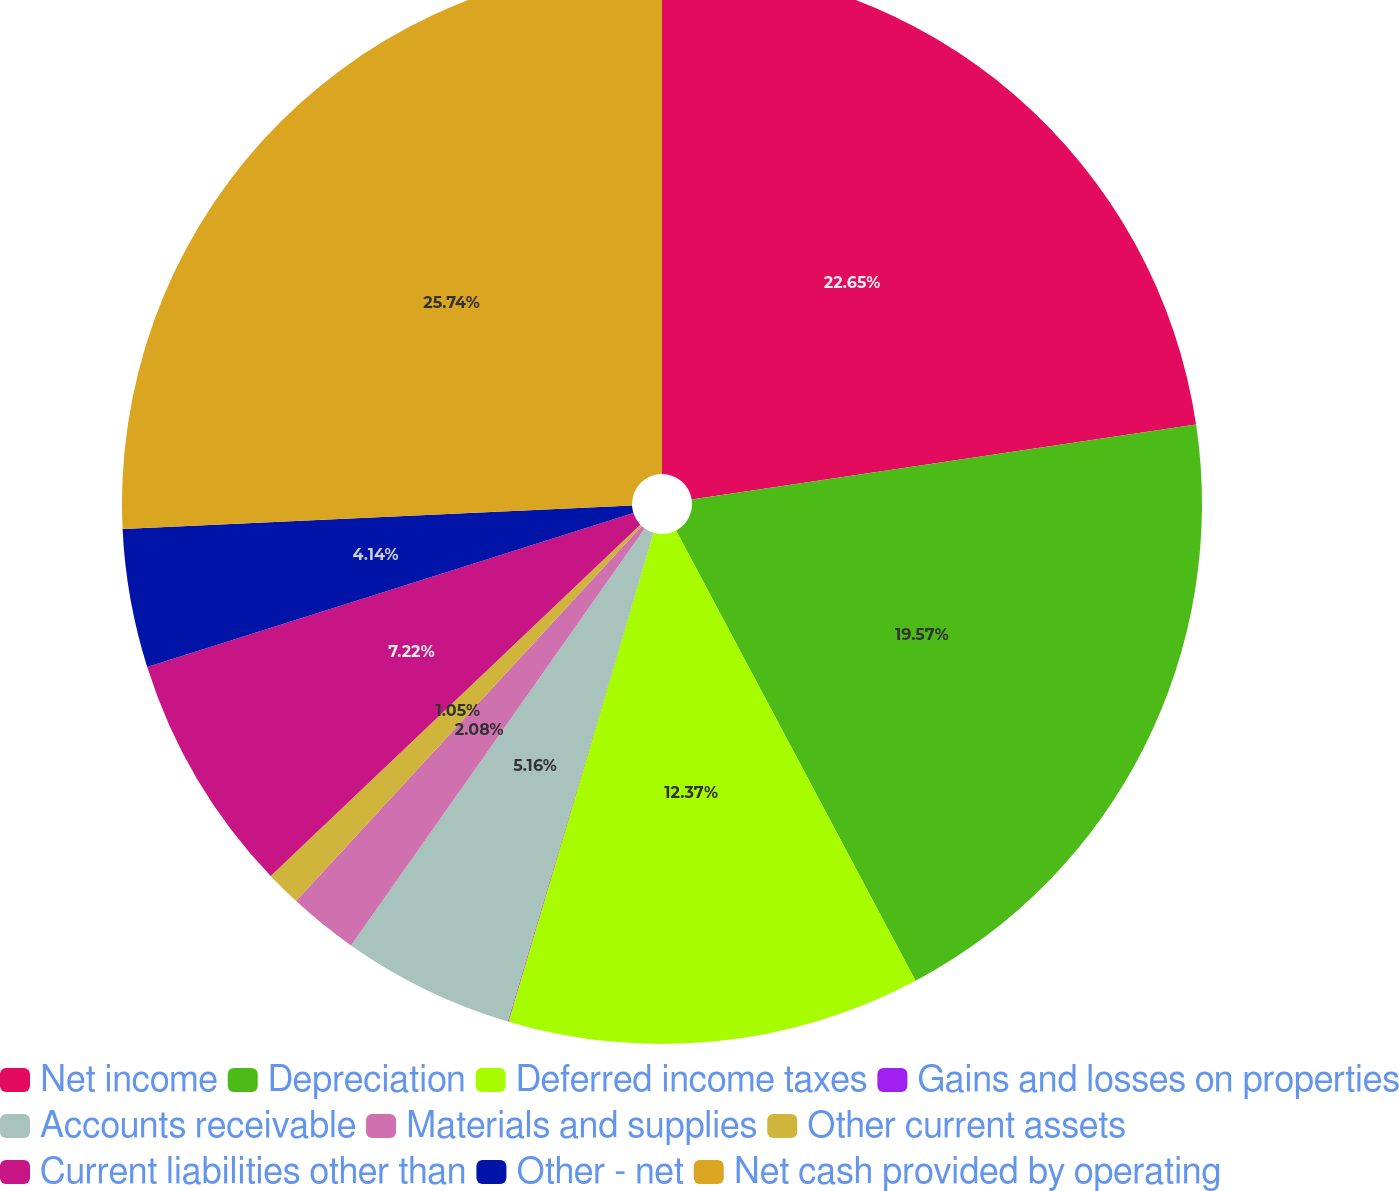<chart> <loc_0><loc_0><loc_500><loc_500><pie_chart><fcel>Net income<fcel>Depreciation<fcel>Deferred income taxes<fcel>Gains and losses on properties<fcel>Accounts receivable<fcel>Materials and supplies<fcel>Other current assets<fcel>Current liabilities other than<fcel>Other - net<fcel>Net cash provided by operating<nl><fcel>22.65%<fcel>19.57%<fcel>12.37%<fcel>0.02%<fcel>5.16%<fcel>2.08%<fcel>1.05%<fcel>7.22%<fcel>4.14%<fcel>25.74%<nl></chart> 